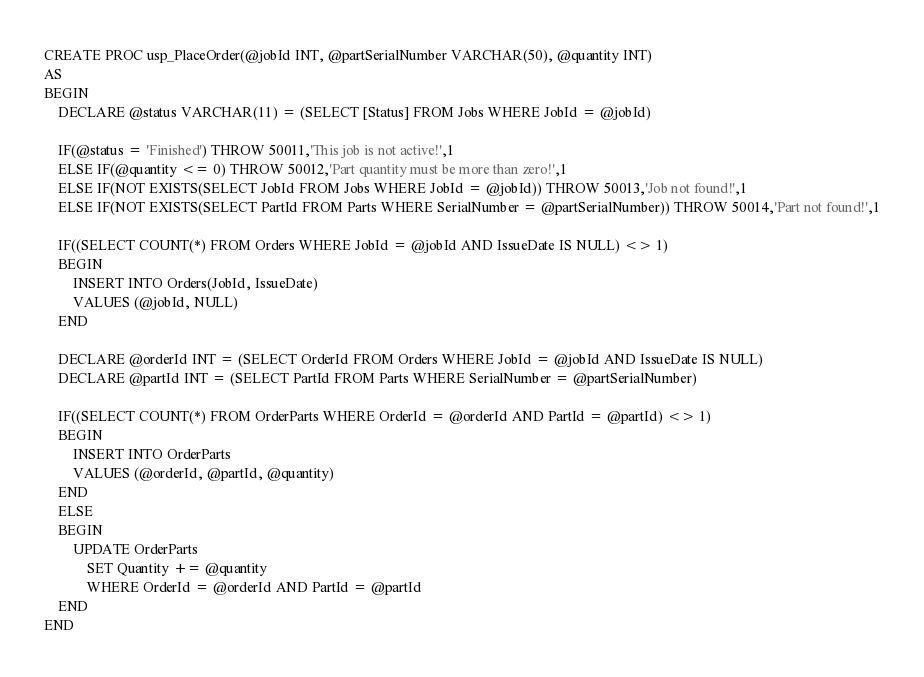<code> <loc_0><loc_0><loc_500><loc_500><_SQL_>CREATE PROC usp_PlaceOrder(@jobId INT, @partSerialNumber VARCHAR(50), @quantity INT)
AS
BEGIN
	DECLARE @status VARCHAR(11) = (SELECT [Status] FROM Jobs WHERE JobId = @jobId)

	IF(@status = 'Finished') THROW 50011,'This job is not active!',1
	ELSE IF(@quantity <= 0) THROW 50012,'Part quantity must be more than zero!',1
	ELSE IF(NOT EXISTS(SELECT JobId FROM Jobs WHERE JobId = @jobId)) THROW 50013,'Job not found!',1
	ELSE IF(NOT EXISTS(SELECT PartId FROM Parts WHERE SerialNumber = @partSerialNumber)) THROW 50014,'Part not found!',1

	IF((SELECT COUNT(*) FROM Orders WHERE JobId = @jobId AND IssueDate IS NULL) <> 1)
	BEGIN
		INSERT INTO Orders(JobId, IssueDate)
		VALUES (@jobId, NULL)
	END

	DECLARE @orderId INT = (SELECT OrderId FROM Orders WHERE JobId = @jobId AND IssueDate IS NULL)
	DECLARE @partId INT = (SELECT PartId FROM Parts WHERE SerialNumber = @partSerialNumber)

	IF((SELECT COUNT(*) FROM OrderParts WHERE OrderId = @orderId AND PartId = @partId) <> 1)
	BEGIN
		INSERT INTO OrderParts
		VALUES (@orderId, @partId, @quantity)
	END
	ELSE
	BEGIN
		UPDATE OrderParts
			SET Quantity += @quantity
			WHERE OrderId = @orderId AND PartId = @partId
	END
END</code> 